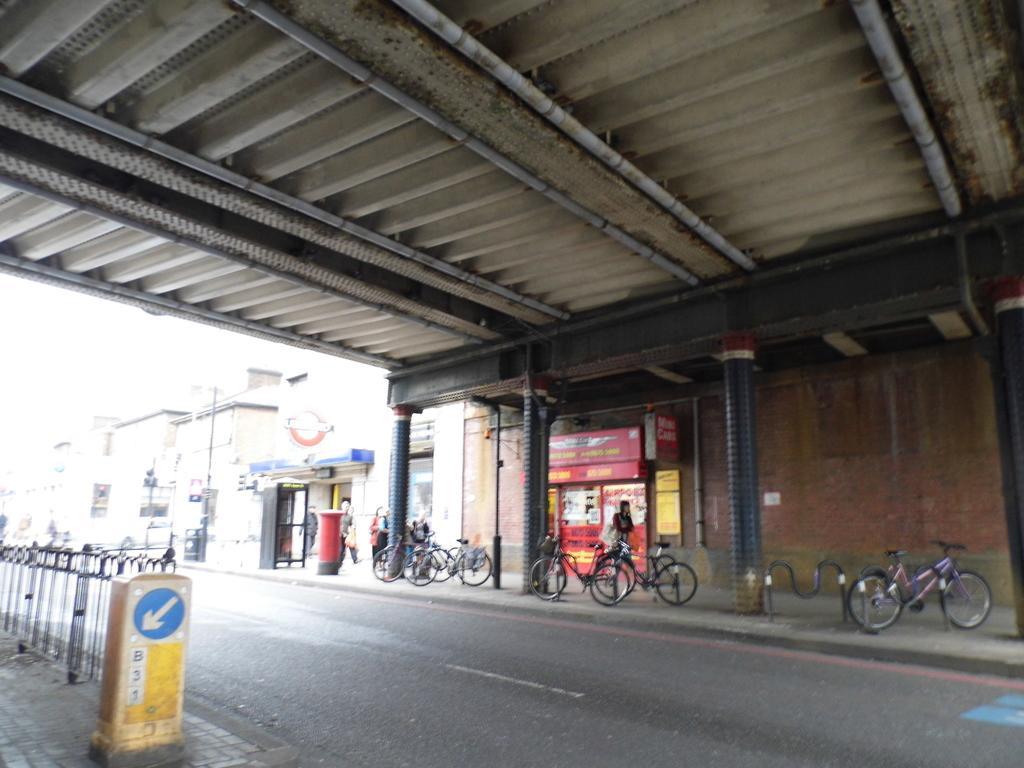In one or two sentences, can you explain what this image depicts? In this picture we can see the road, here we can see people, bicycles, pillars, wall, roof and some objects and in the background we can see buildings. 